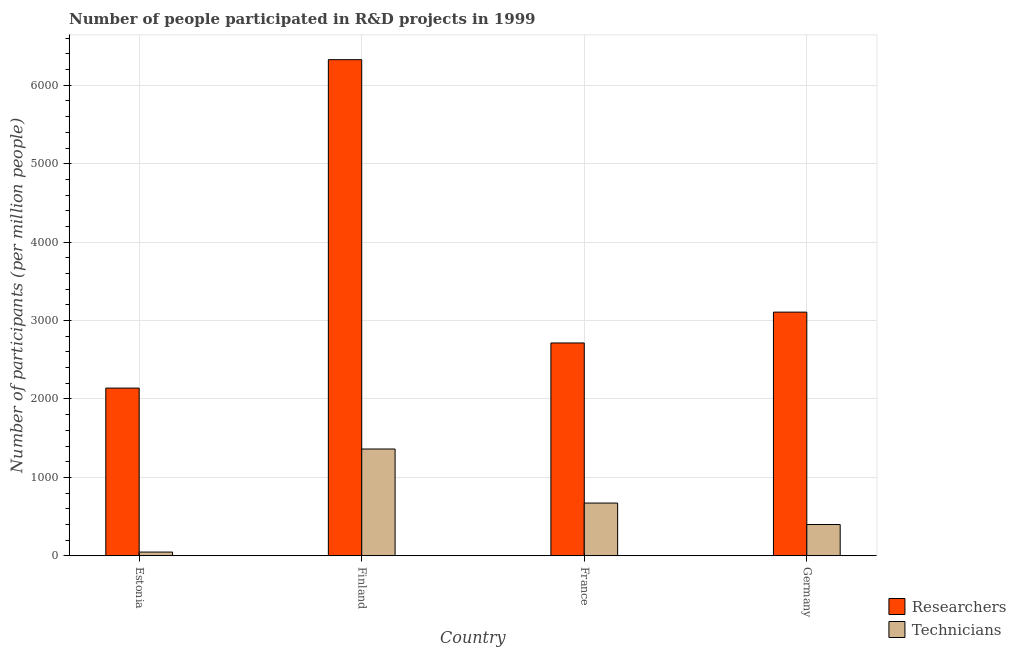How many bars are there on the 1st tick from the right?
Your answer should be very brief. 2. What is the label of the 2nd group of bars from the left?
Provide a succinct answer. Finland. In how many cases, is the number of bars for a given country not equal to the number of legend labels?
Your answer should be compact. 0. What is the number of researchers in Estonia?
Give a very brief answer. 2138.45. Across all countries, what is the maximum number of researchers?
Make the answer very short. 6326.7. Across all countries, what is the minimum number of technicians?
Keep it short and to the point. 47.51. In which country was the number of researchers minimum?
Provide a succinct answer. Estonia. What is the total number of technicians in the graph?
Provide a short and direct response. 2480.71. What is the difference between the number of researchers in Estonia and that in Finland?
Your answer should be very brief. -4188.25. What is the difference between the number of technicians in Estonia and the number of researchers in Germany?
Your answer should be very brief. -3059.77. What is the average number of technicians per country?
Provide a succinct answer. 620.18. What is the difference between the number of technicians and number of researchers in France?
Offer a terse response. -2041.51. What is the ratio of the number of researchers in Estonia to that in France?
Your response must be concise. 0.79. Is the number of technicians in France less than that in Germany?
Provide a succinct answer. No. What is the difference between the highest and the second highest number of technicians?
Your answer should be compact. 689.17. What is the difference between the highest and the lowest number of researchers?
Ensure brevity in your answer.  4188.25. Is the sum of the number of researchers in Finland and Germany greater than the maximum number of technicians across all countries?
Keep it short and to the point. Yes. What does the 2nd bar from the left in Finland represents?
Your answer should be compact. Technicians. What does the 2nd bar from the right in France represents?
Provide a succinct answer. Researchers. How many countries are there in the graph?
Make the answer very short. 4. Does the graph contain any zero values?
Ensure brevity in your answer.  No. Does the graph contain grids?
Offer a very short reply. Yes. Where does the legend appear in the graph?
Provide a short and direct response. Bottom right. How are the legend labels stacked?
Your answer should be very brief. Vertical. What is the title of the graph?
Provide a succinct answer. Number of people participated in R&D projects in 1999. Does "Age 65(female)" appear as one of the legend labels in the graph?
Your answer should be compact. No. What is the label or title of the X-axis?
Your answer should be compact. Country. What is the label or title of the Y-axis?
Keep it short and to the point. Number of participants (per million people). What is the Number of participants (per million people) in Researchers in Estonia?
Offer a terse response. 2138.45. What is the Number of participants (per million people) in Technicians in Estonia?
Your response must be concise. 47.51. What is the Number of participants (per million people) of Researchers in Finland?
Ensure brevity in your answer.  6326.7. What is the Number of participants (per million people) in Technicians in Finland?
Make the answer very short. 1361.76. What is the Number of participants (per million people) in Researchers in France?
Provide a succinct answer. 2714.09. What is the Number of participants (per million people) in Technicians in France?
Provide a succinct answer. 672.59. What is the Number of participants (per million people) of Researchers in Germany?
Offer a terse response. 3107.28. What is the Number of participants (per million people) of Technicians in Germany?
Offer a terse response. 398.85. Across all countries, what is the maximum Number of participants (per million people) of Researchers?
Offer a very short reply. 6326.7. Across all countries, what is the maximum Number of participants (per million people) of Technicians?
Make the answer very short. 1361.76. Across all countries, what is the minimum Number of participants (per million people) of Researchers?
Offer a very short reply. 2138.45. Across all countries, what is the minimum Number of participants (per million people) in Technicians?
Your answer should be very brief. 47.51. What is the total Number of participants (per million people) of Researchers in the graph?
Give a very brief answer. 1.43e+04. What is the total Number of participants (per million people) of Technicians in the graph?
Make the answer very short. 2480.71. What is the difference between the Number of participants (per million people) of Researchers in Estonia and that in Finland?
Provide a short and direct response. -4188.25. What is the difference between the Number of participants (per million people) in Technicians in Estonia and that in Finland?
Give a very brief answer. -1314.25. What is the difference between the Number of participants (per million people) in Researchers in Estonia and that in France?
Ensure brevity in your answer.  -575.65. What is the difference between the Number of participants (per million people) in Technicians in Estonia and that in France?
Ensure brevity in your answer.  -625.08. What is the difference between the Number of participants (per million people) in Researchers in Estonia and that in Germany?
Keep it short and to the point. -968.83. What is the difference between the Number of participants (per million people) in Technicians in Estonia and that in Germany?
Keep it short and to the point. -351.34. What is the difference between the Number of participants (per million people) in Researchers in Finland and that in France?
Your response must be concise. 3612.6. What is the difference between the Number of participants (per million people) in Technicians in Finland and that in France?
Offer a very short reply. 689.17. What is the difference between the Number of participants (per million people) in Researchers in Finland and that in Germany?
Your response must be concise. 3219.41. What is the difference between the Number of participants (per million people) of Technicians in Finland and that in Germany?
Keep it short and to the point. 962.9. What is the difference between the Number of participants (per million people) of Researchers in France and that in Germany?
Give a very brief answer. -393.19. What is the difference between the Number of participants (per million people) in Technicians in France and that in Germany?
Your answer should be very brief. 273.73. What is the difference between the Number of participants (per million people) in Researchers in Estonia and the Number of participants (per million people) in Technicians in Finland?
Your response must be concise. 776.69. What is the difference between the Number of participants (per million people) of Researchers in Estonia and the Number of participants (per million people) of Technicians in France?
Offer a very short reply. 1465.86. What is the difference between the Number of participants (per million people) of Researchers in Estonia and the Number of participants (per million people) of Technicians in Germany?
Keep it short and to the point. 1739.6. What is the difference between the Number of participants (per million people) of Researchers in Finland and the Number of participants (per million people) of Technicians in France?
Keep it short and to the point. 5654.11. What is the difference between the Number of participants (per million people) in Researchers in Finland and the Number of participants (per million people) in Technicians in Germany?
Give a very brief answer. 5927.84. What is the difference between the Number of participants (per million people) in Researchers in France and the Number of participants (per million people) in Technicians in Germany?
Make the answer very short. 2315.24. What is the average Number of participants (per million people) of Researchers per country?
Provide a short and direct response. 3571.63. What is the average Number of participants (per million people) of Technicians per country?
Your answer should be compact. 620.18. What is the difference between the Number of participants (per million people) in Researchers and Number of participants (per million people) in Technicians in Estonia?
Make the answer very short. 2090.94. What is the difference between the Number of participants (per million people) of Researchers and Number of participants (per million people) of Technicians in Finland?
Offer a terse response. 4964.94. What is the difference between the Number of participants (per million people) of Researchers and Number of participants (per million people) of Technicians in France?
Offer a terse response. 2041.51. What is the difference between the Number of participants (per million people) of Researchers and Number of participants (per million people) of Technicians in Germany?
Give a very brief answer. 2708.43. What is the ratio of the Number of participants (per million people) of Researchers in Estonia to that in Finland?
Ensure brevity in your answer.  0.34. What is the ratio of the Number of participants (per million people) in Technicians in Estonia to that in Finland?
Your answer should be compact. 0.03. What is the ratio of the Number of participants (per million people) in Researchers in Estonia to that in France?
Offer a terse response. 0.79. What is the ratio of the Number of participants (per million people) in Technicians in Estonia to that in France?
Provide a succinct answer. 0.07. What is the ratio of the Number of participants (per million people) of Researchers in Estonia to that in Germany?
Your answer should be compact. 0.69. What is the ratio of the Number of participants (per million people) of Technicians in Estonia to that in Germany?
Ensure brevity in your answer.  0.12. What is the ratio of the Number of participants (per million people) in Researchers in Finland to that in France?
Your answer should be very brief. 2.33. What is the ratio of the Number of participants (per million people) of Technicians in Finland to that in France?
Offer a very short reply. 2.02. What is the ratio of the Number of participants (per million people) in Researchers in Finland to that in Germany?
Provide a short and direct response. 2.04. What is the ratio of the Number of participants (per million people) in Technicians in Finland to that in Germany?
Your answer should be compact. 3.41. What is the ratio of the Number of participants (per million people) of Researchers in France to that in Germany?
Keep it short and to the point. 0.87. What is the ratio of the Number of participants (per million people) of Technicians in France to that in Germany?
Offer a terse response. 1.69. What is the difference between the highest and the second highest Number of participants (per million people) in Researchers?
Offer a terse response. 3219.41. What is the difference between the highest and the second highest Number of participants (per million people) of Technicians?
Offer a terse response. 689.17. What is the difference between the highest and the lowest Number of participants (per million people) of Researchers?
Offer a terse response. 4188.25. What is the difference between the highest and the lowest Number of participants (per million people) in Technicians?
Make the answer very short. 1314.25. 